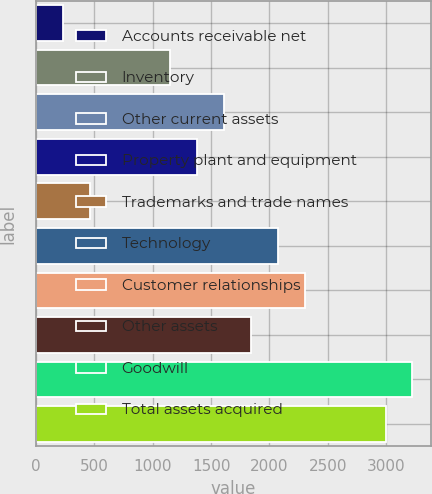Convert chart. <chart><loc_0><loc_0><loc_500><loc_500><bar_chart><fcel>Accounts receivable net<fcel>Inventory<fcel>Other current assets<fcel>Property plant and equipment<fcel>Trademarks and trade names<fcel>Technology<fcel>Customer relationships<fcel>Other assets<fcel>Goodwill<fcel>Total assets acquired<nl><fcel>231<fcel>1152.2<fcel>1612.8<fcel>1382.5<fcel>461.3<fcel>2073.4<fcel>2303.7<fcel>1843.1<fcel>3224.9<fcel>2994.6<nl></chart> 